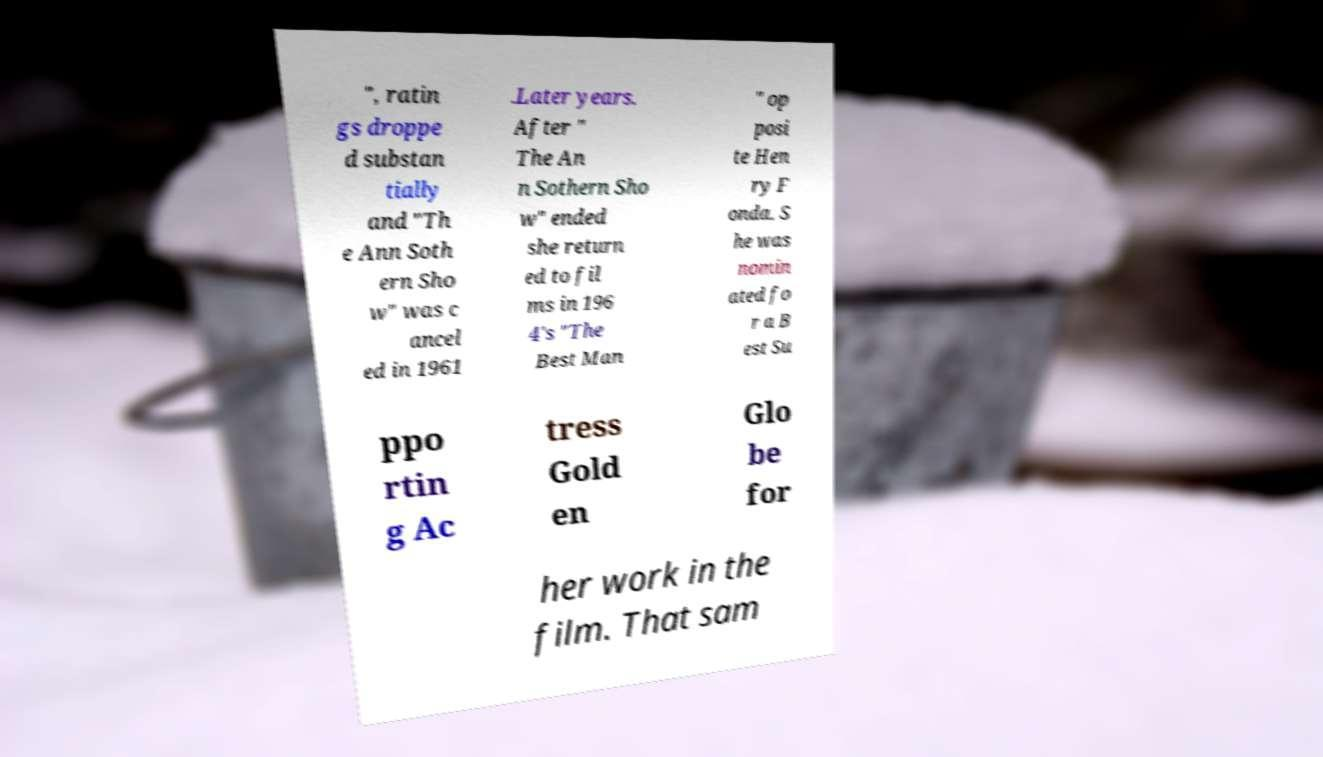For documentation purposes, I need the text within this image transcribed. Could you provide that? ", ratin gs droppe d substan tially and "Th e Ann Soth ern Sho w" was c ancel ed in 1961 .Later years. After " The An n Sothern Sho w" ended she return ed to fil ms in 196 4's "The Best Man " op posi te Hen ry F onda. S he was nomin ated fo r a B est Su ppo rtin g Ac tress Gold en Glo be for her work in the film. That sam 